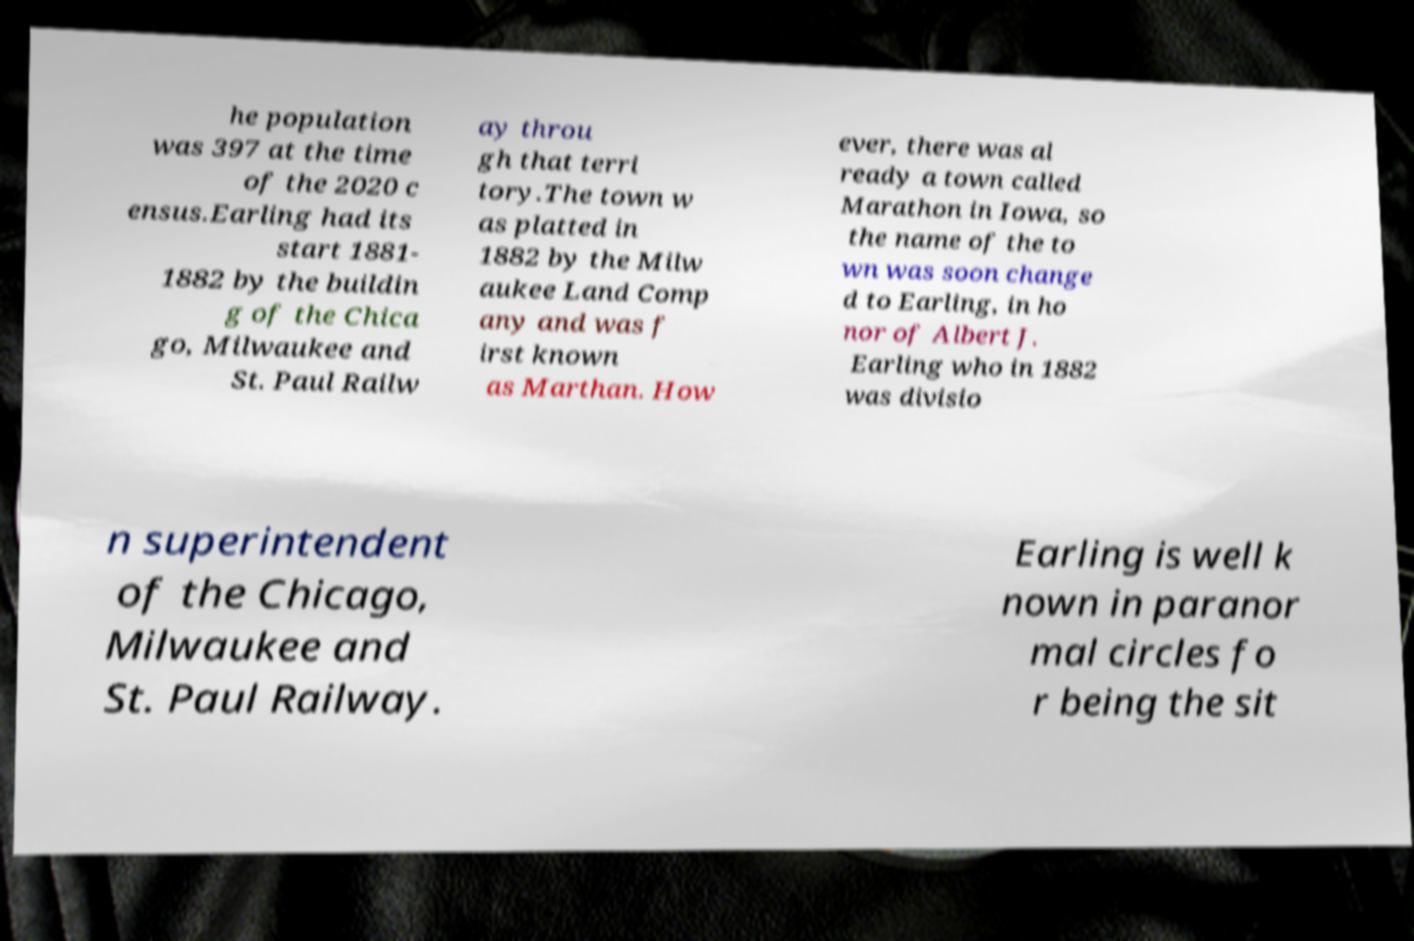I need the written content from this picture converted into text. Can you do that? he population was 397 at the time of the 2020 c ensus.Earling had its start 1881- 1882 by the buildin g of the Chica go, Milwaukee and St. Paul Railw ay throu gh that terri tory.The town w as platted in 1882 by the Milw aukee Land Comp any and was f irst known as Marthan. How ever, there was al ready a town called Marathon in Iowa, so the name of the to wn was soon change d to Earling, in ho nor of Albert J. Earling who in 1882 was divisio n superintendent of the Chicago, Milwaukee and St. Paul Railway. Earling is well k nown in paranor mal circles fo r being the sit 